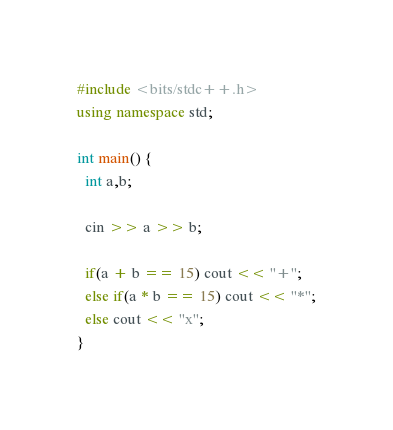<code> <loc_0><loc_0><loc_500><loc_500><_C++_>#include <bits/stdc++.h>
using namespace std;

int main() {
  int a,b;
  
  cin >> a >> b;
  
  if(a + b == 15) cout << "+";
  else if(a * b == 15) cout << "*";
  else cout << "x";
}</code> 